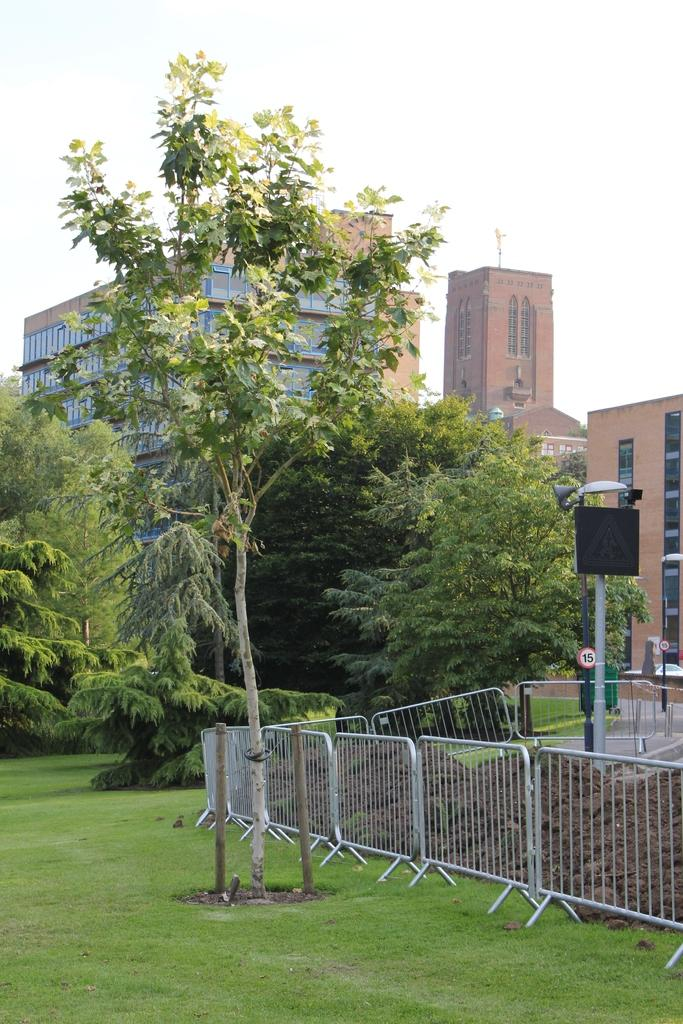What type of vegetation can be seen in the image? There are trees in the image. What type of structure is present in the image? There is a fence in the image. What other objects can be seen in the image? There are poles in the image. What is the ground covered with in the image? There is grass in the image. What type of man-made structures are visible in the image? There are buildings in the image. What is visible in the background of the image? The sky is visible in the background of the image. What type of bead is hanging from the tree in the image? There is no bead present in the image. Can you identify the actor in the image? There are no actors present in the image. What type of fruit is growing on the poles in the image? There are no fruits growing on the poles in the image. 